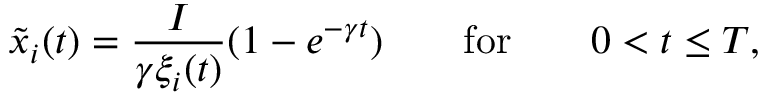Convert formula to latex. <formula><loc_0><loc_0><loc_500><loc_500>\tilde { x } _ { i } ( t ) = \frac { I } { \gamma \xi _ { i } ( t ) } ( 1 - e ^ { - \gamma t } ) \quad f o r \quad 0 < t \leq T ,</formula> 